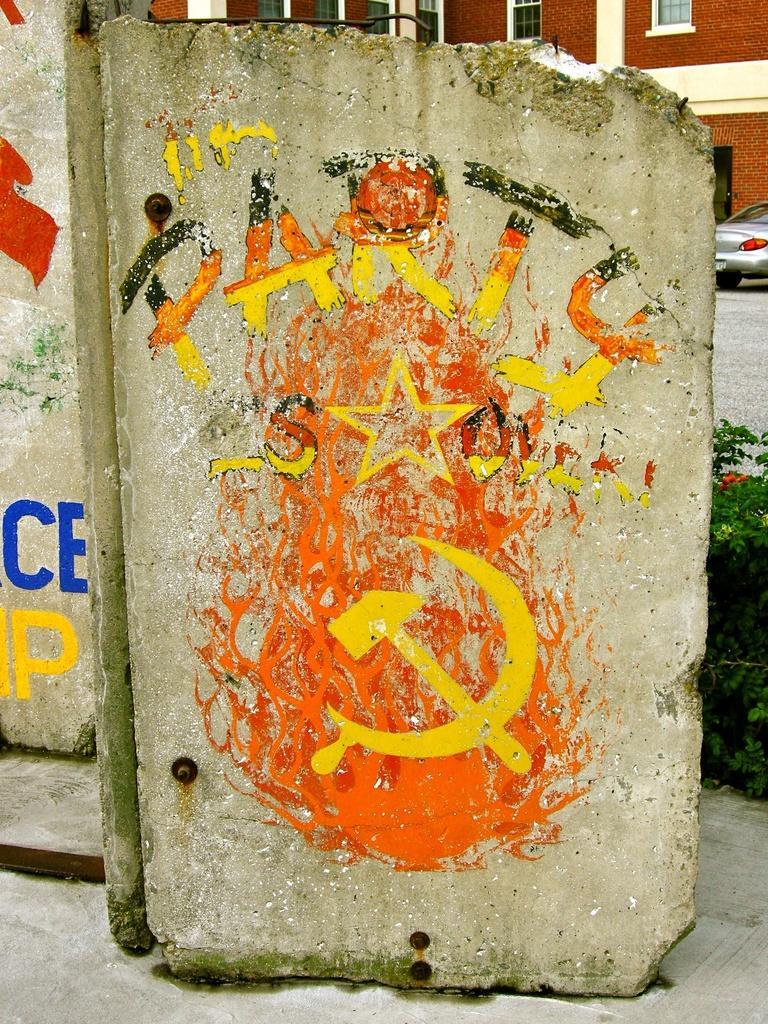How would you summarize this image in a sentence or two? This image consists of a rock on which there is a painting and a text. At the bottom, there is road. In the background, we can see a car and a building. On the right, we can see small plants. 